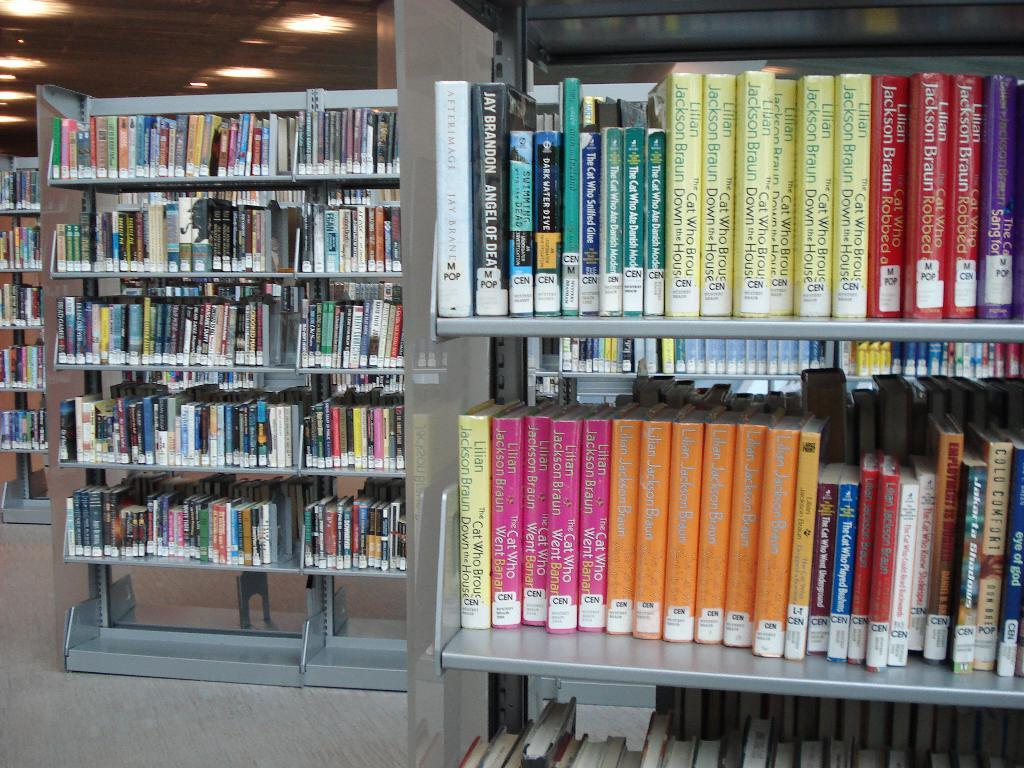What type of place is depicted in the image? The image appears to be taken in a library. What can be seen on the shelves in the library? There are books kept in a rack in the image. What part of the library is visible at the bottom of the image? The floor is visible at the bottom of the image. What provides illumination in the library? There are lights near the roof in the image. What type of dinner is being served in the library in the image? There is no dinner being served in the library in the image; it is a place for keeping books. Who is the achiever being celebrated in the library in the image? There is no celebration or achievement being depicted in the image; it is a typical library scene. 